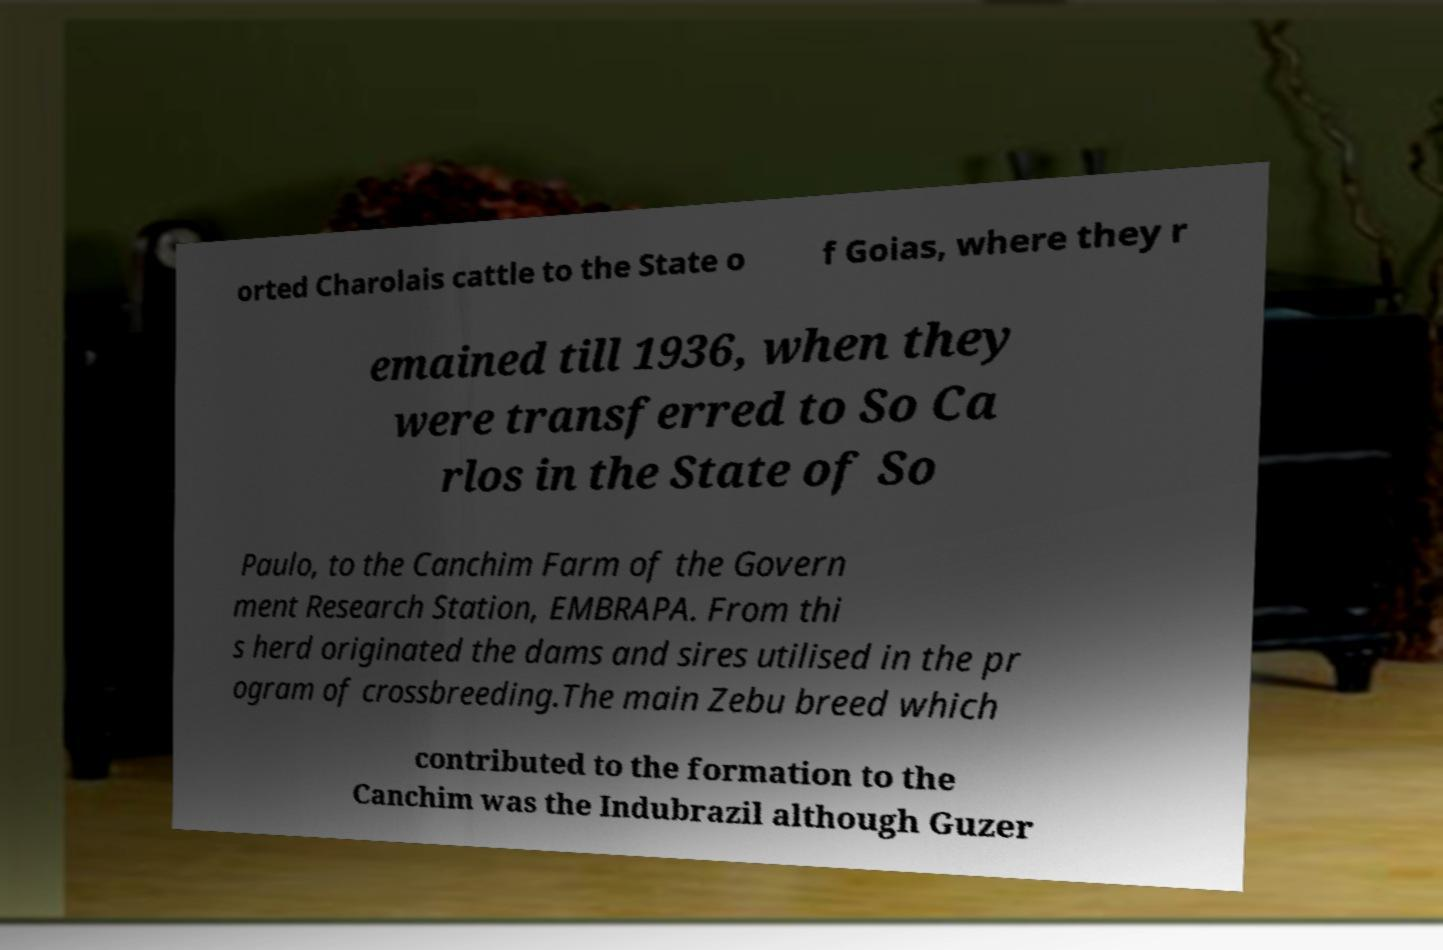What messages or text are displayed in this image? I need them in a readable, typed format. orted Charolais cattle to the State o f Goias, where they r emained till 1936, when they were transferred to So Ca rlos in the State of So Paulo, to the Canchim Farm of the Govern ment Research Station, EMBRAPA. From thi s herd originated the dams and sires utilised in the pr ogram of crossbreeding.The main Zebu breed which contributed to the formation to the Canchim was the Indubrazil although Guzer 